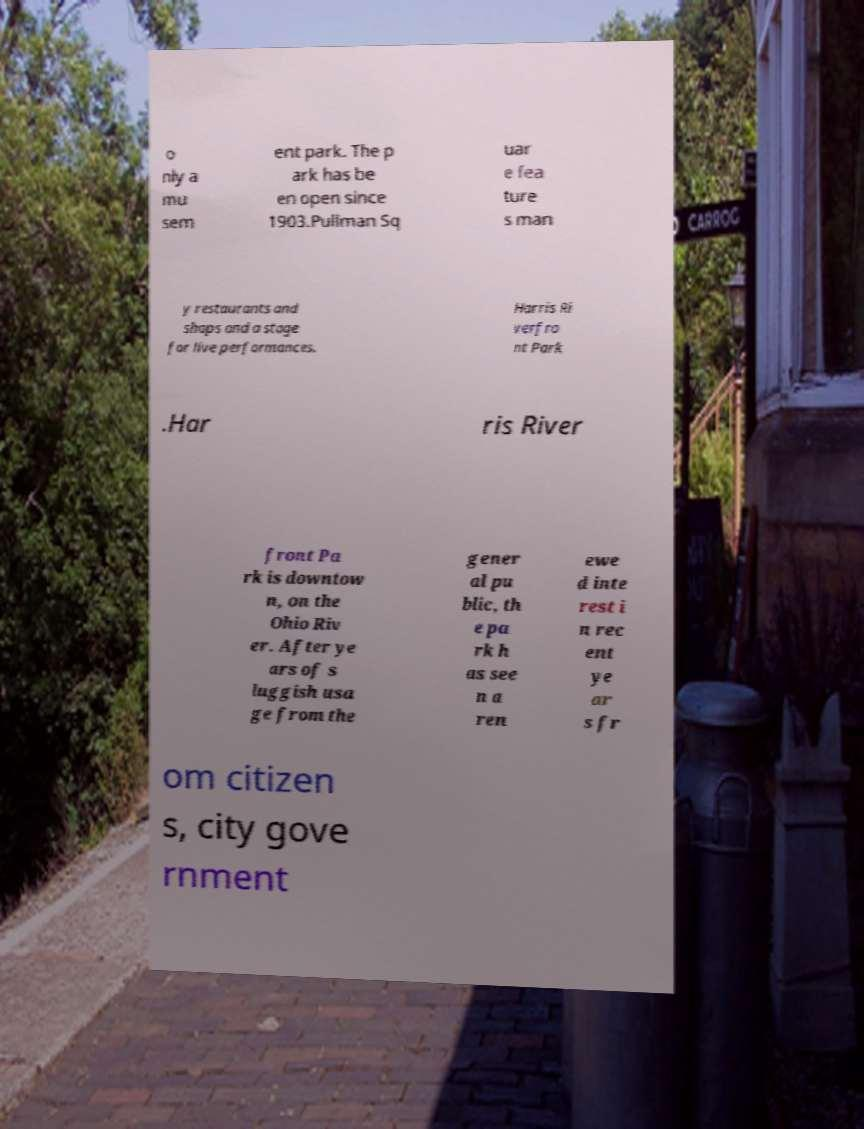Can you accurately transcribe the text from the provided image for me? o nly a mu sem ent park. The p ark has be en open since 1903.Pullman Sq uar e fea ture s man y restaurants and shops and a stage for live performances. Harris Ri verfro nt Park .Har ris River front Pa rk is downtow n, on the Ohio Riv er. After ye ars of s luggish usa ge from the gener al pu blic, th e pa rk h as see n a ren ewe d inte rest i n rec ent ye ar s fr om citizen s, city gove rnment 